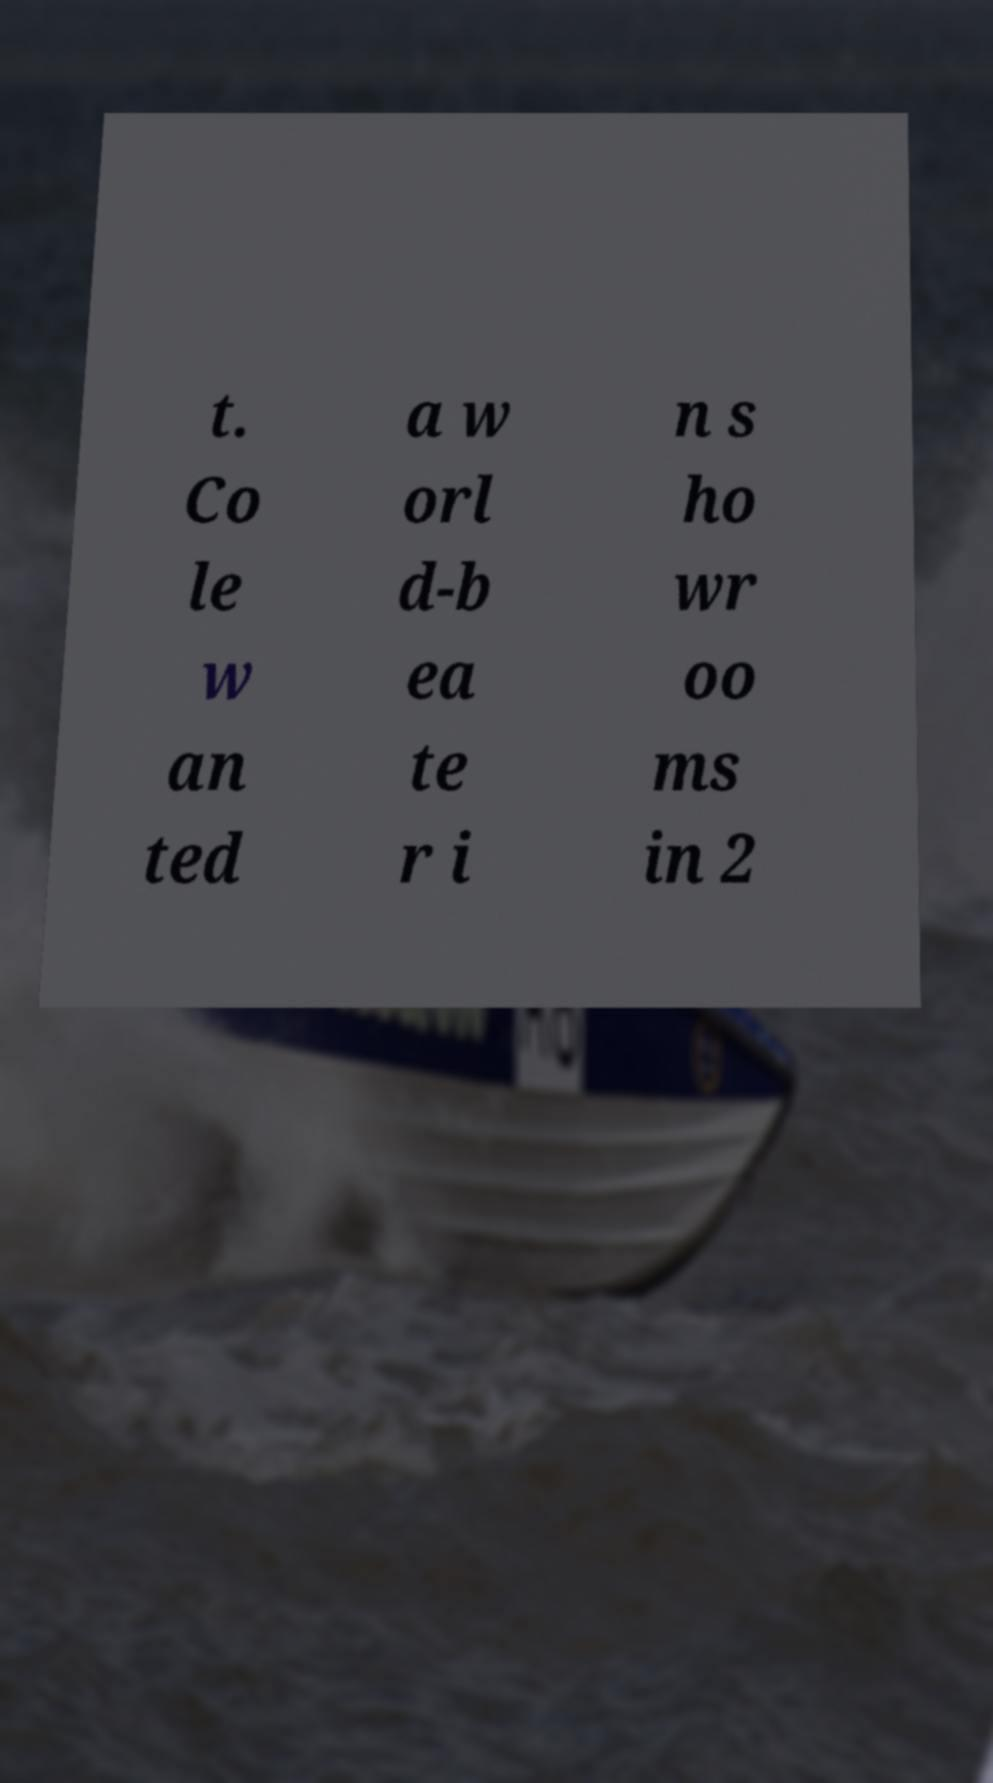Please identify and transcribe the text found in this image. t. Co le w an ted a w orl d-b ea te r i n s ho wr oo ms in 2 